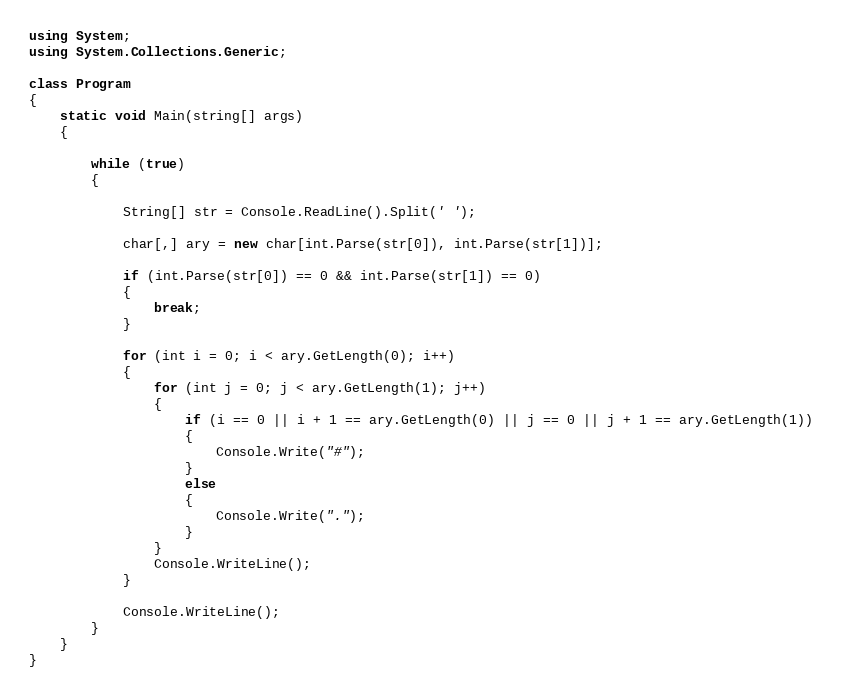<code> <loc_0><loc_0><loc_500><loc_500><_C#_>using System;
using System.Collections.Generic;

class Program
{
    static void Main(string[] args)
    {

        while (true)
        {

            String[] str = Console.ReadLine().Split(' ');

            char[,] ary = new char[int.Parse(str[0]), int.Parse(str[1])];

            if (int.Parse(str[0]) == 0 && int.Parse(str[1]) == 0)
            {
                break;
            }

            for (int i = 0; i < ary.GetLength(0); i++)
            {
                for (int j = 0; j < ary.GetLength(1); j++)
                {
                    if (i == 0 || i + 1 == ary.GetLength(0) || j == 0 || j + 1 == ary.GetLength(1))
                    {
                        Console.Write("#");
                    }
                    else
                    {
                        Console.Write(".");
                    }
                }
                Console.WriteLine();
            }

            Console.WriteLine();
        }
    }
}</code> 